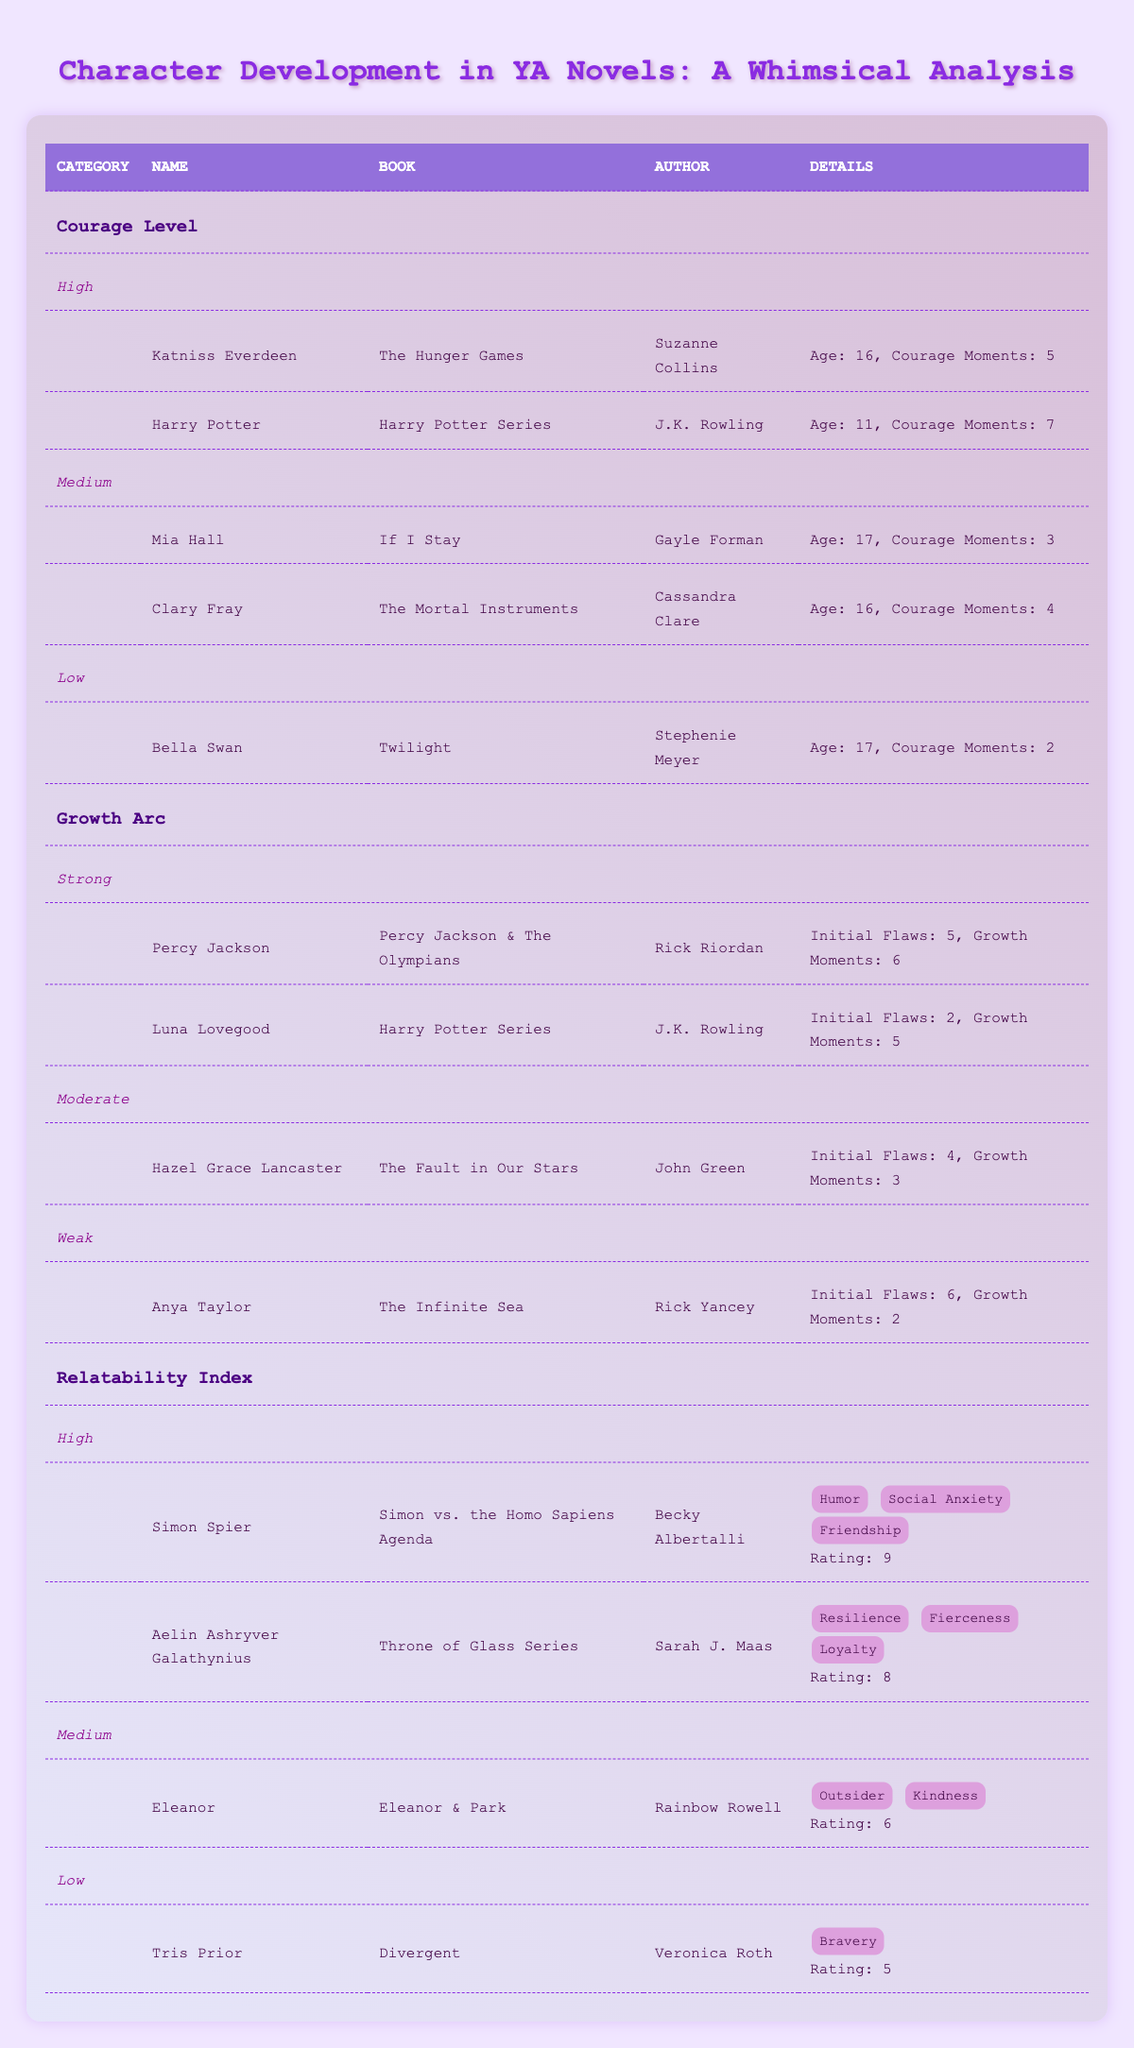What is the name of the protagonist with the highest courage moments? Looking through the "Courage Level" section of the table, Harry Potter has the most courage moments, totaling 7, compared to the others.
Answer: Harry Potter How many courage moments does Mia Hall have? In the "Courage Level" section, Mia Hall is listed under the Medium courage category with 3 courage moments.
Answer: 3 Is Hazel Grace Lancaster characterized by a weak growth arc? Hazel Grace Lancaster appears under the "Moderate" growth arc category with 4 initial flaws and 3 growth moments, indicating she does not have a weak growth arc.
Answer: No What is the average rating for protagonists with a high relatability index? The high relatability index contains two protagonists: Simon Spier with a rating of 9 and Aelin Ashryver Galathynius with a rating of 8. Their total sum is 9 + 8 = 17. Dividing by the number of protagonists (2) gives an average rating of 17/2 = 8.5.
Answer: 8.5 Which protagonist has the strongest growth arc according to the table? The "Growth Arc" section identifies Percy Jackson as having the strongest growth arc, with 5 initial flaws and 6 growth moments, compared to other characters listed.
Answer: Percy Jackson How many characters have a low correlativity index? In the "Relatability Index" section, there is one character with a low rating, Tris Prior. Therefore, there is only one character in this category.
Answer: 1 Is Katniss Everdeen older than Harry Potter? According to the "Courage Level" section, Katniss Everdeen is 16 years old, while Harry Potter is 11 years old, therefore Katniss is older.
Answer: Yes What is the total number of courage moments for all protagonists listed in the high courage category? The high courage category contains Katniss Everdeen with 5 courage moments and Harry Potter with 7 courage moments. Totaling these gives 5 + 7 = 12 courage moments altogether.
Answer: 12 How many initial flaws does Anya Taylor have compared to Percy Jackson? Anya Taylor has 6 initial flaws while Percy Jackson has 5 initial flaws, which shows that Anya has 1 more initial flaw than Percy.
Answer: Anya Taylor has 1 more initial flaw than Percy Jackson 